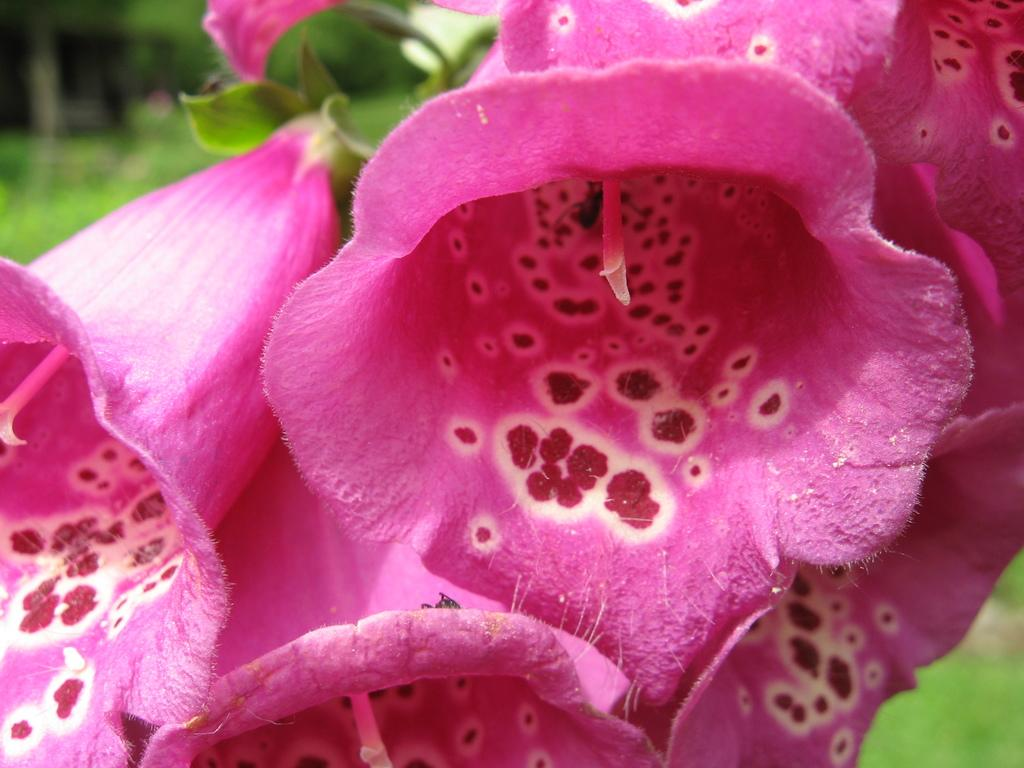What type of flowers are present in the image? There are pink flowers in the image. Can you describe the background of the image? The background of the image is blurred. How many holes can be seen in the pink flowers in the image? There are no holes present in the pink flowers in the image. 